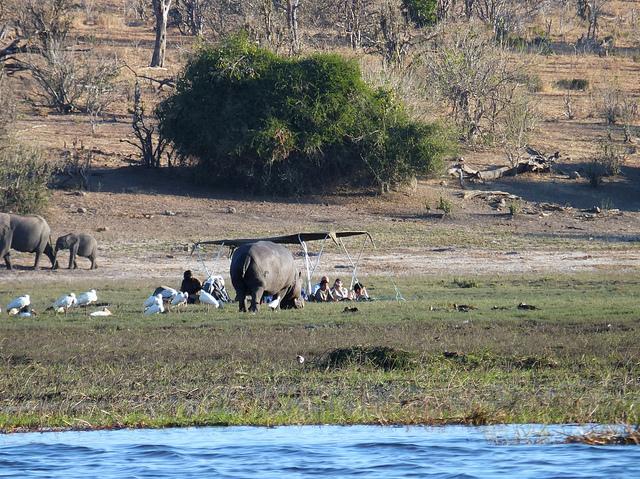Is the water calm?
Be succinct. Yes. What are the large animals called?
Concise answer only. Elephants. Is the hippo going toward the people?
Be succinct. Yes. 